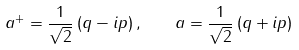<formula> <loc_0><loc_0><loc_500><loc_500>a ^ { + } = \frac { 1 } { \sqrt { 2 } } \left ( q - i p \right ) , \quad a = \frac { 1 } { \sqrt { 2 } } \left ( q + i p \right )</formula> 